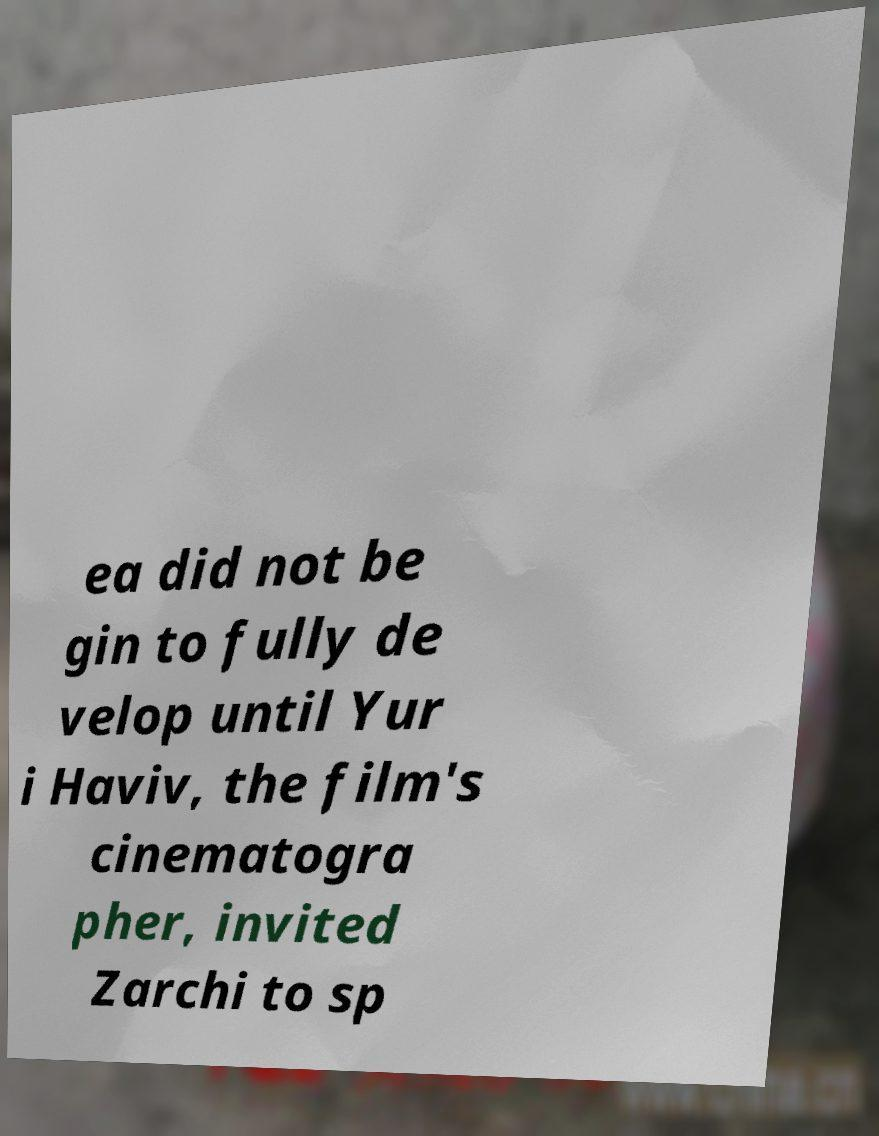What messages or text are displayed in this image? I need them in a readable, typed format. ea did not be gin to fully de velop until Yur i Haviv, the film's cinematogra pher, invited Zarchi to sp 